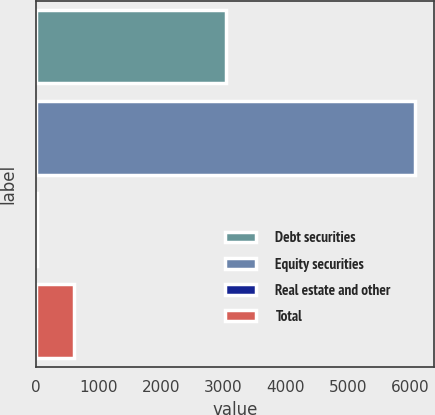Convert chart. <chart><loc_0><loc_0><loc_500><loc_500><bar_chart><fcel>Debt securities<fcel>Equity securities<fcel>Real estate and other<fcel>Total<nl><fcel>3040<fcel>6070<fcel>5<fcel>611.5<nl></chart> 